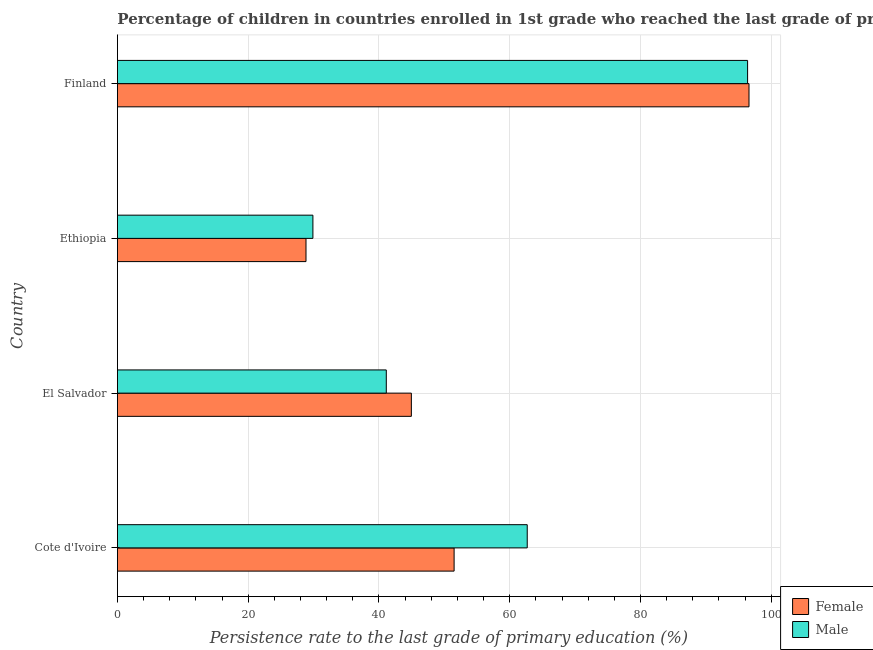How many different coloured bars are there?
Ensure brevity in your answer.  2. How many groups of bars are there?
Your answer should be very brief. 4. Are the number of bars per tick equal to the number of legend labels?
Ensure brevity in your answer.  Yes. How many bars are there on the 3rd tick from the top?
Your response must be concise. 2. How many bars are there on the 3rd tick from the bottom?
Your answer should be compact. 2. In how many cases, is the number of bars for a given country not equal to the number of legend labels?
Offer a very short reply. 0. What is the persistence rate of female students in Ethiopia?
Keep it short and to the point. 28.84. Across all countries, what is the maximum persistence rate of female students?
Offer a very short reply. 96.59. Across all countries, what is the minimum persistence rate of male students?
Provide a short and direct response. 29.9. In which country was the persistence rate of female students minimum?
Provide a succinct answer. Ethiopia. What is the total persistence rate of male students in the graph?
Offer a very short reply. 230.08. What is the difference between the persistence rate of male students in El Salvador and that in Ethiopia?
Provide a short and direct response. 11.22. What is the difference between the persistence rate of male students in Finland and the persistence rate of female students in El Salvador?
Your answer should be very brief. 51.42. What is the average persistence rate of male students per country?
Keep it short and to the point. 57.52. What is the difference between the persistence rate of male students and persistence rate of female students in Cote d'Ivoire?
Your answer should be very brief. 11.18. What is the ratio of the persistence rate of female students in Ethiopia to that in Finland?
Offer a terse response. 0.3. Is the persistence rate of female students in Cote d'Ivoire less than that in El Salvador?
Ensure brevity in your answer.  No. What is the difference between the highest and the second highest persistence rate of female students?
Provide a short and direct response. 45.1. What is the difference between the highest and the lowest persistence rate of female students?
Offer a terse response. 67.75. What does the 2nd bar from the top in Finland represents?
Your response must be concise. Female. What does the 1st bar from the bottom in El Salvador represents?
Give a very brief answer. Female. Are all the bars in the graph horizontal?
Your response must be concise. Yes. How many countries are there in the graph?
Your answer should be very brief. 4. What is the difference between two consecutive major ticks on the X-axis?
Make the answer very short. 20. Does the graph contain grids?
Your answer should be very brief. Yes. Where does the legend appear in the graph?
Keep it short and to the point. Bottom right. How many legend labels are there?
Provide a succinct answer. 2. How are the legend labels stacked?
Provide a succinct answer. Vertical. What is the title of the graph?
Provide a short and direct response. Percentage of children in countries enrolled in 1st grade who reached the last grade of primary education. What is the label or title of the X-axis?
Make the answer very short. Persistence rate to the last grade of primary education (%). What is the Persistence rate to the last grade of primary education (%) of Female in Cote d'Ivoire?
Make the answer very short. 51.49. What is the Persistence rate to the last grade of primary education (%) of Male in Cote d'Ivoire?
Your answer should be very brief. 62.68. What is the Persistence rate to the last grade of primary education (%) of Female in El Salvador?
Provide a succinct answer. 44.96. What is the Persistence rate to the last grade of primary education (%) in Male in El Salvador?
Provide a succinct answer. 41.12. What is the Persistence rate to the last grade of primary education (%) of Female in Ethiopia?
Offer a terse response. 28.84. What is the Persistence rate to the last grade of primary education (%) in Male in Ethiopia?
Your answer should be compact. 29.9. What is the Persistence rate to the last grade of primary education (%) in Female in Finland?
Make the answer very short. 96.59. What is the Persistence rate to the last grade of primary education (%) in Male in Finland?
Your answer should be compact. 96.38. Across all countries, what is the maximum Persistence rate to the last grade of primary education (%) in Female?
Ensure brevity in your answer.  96.59. Across all countries, what is the maximum Persistence rate to the last grade of primary education (%) in Male?
Offer a terse response. 96.38. Across all countries, what is the minimum Persistence rate to the last grade of primary education (%) of Female?
Give a very brief answer. 28.84. Across all countries, what is the minimum Persistence rate to the last grade of primary education (%) of Male?
Provide a succinct answer. 29.9. What is the total Persistence rate to the last grade of primary education (%) in Female in the graph?
Give a very brief answer. 221.88. What is the total Persistence rate to the last grade of primary education (%) of Male in the graph?
Offer a terse response. 230.08. What is the difference between the Persistence rate to the last grade of primary education (%) in Female in Cote d'Ivoire and that in El Salvador?
Provide a succinct answer. 6.54. What is the difference between the Persistence rate to the last grade of primary education (%) of Male in Cote d'Ivoire and that in El Salvador?
Provide a short and direct response. 21.55. What is the difference between the Persistence rate to the last grade of primary education (%) of Female in Cote d'Ivoire and that in Ethiopia?
Ensure brevity in your answer.  22.65. What is the difference between the Persistence rate to the last grade of primary education (%) of Male in Cote d'Ivoire and that in Ethiopia?
Your answer should be very brief. 32.78. What is the difference between the Persistence rate to the last grade of primary education (%) in Female in Cote d'Ivoire and that in Finland?
Your response must be concise. -45.1. What is the difference between the Persistence rate to the last grade of primary education (%) of Male in Cote d'Ivoire and that in Finland?
Your answer should be compact. -33.7. What is the difference between the Persistence rate to the last grade of primary education (%) in Female in El Salvador and that in Ethiopia?
Provide a short and direct response. 16.11. What is the difference between the Persistence rate to the last grade of primary education (%) in Male in El Salvador and that in Ethiopia?
Make the answer very short. 11.22. What is the difference between the Persistence rate to the last grade of primary education (%) of Female in El Salvador and that in Finland?
Keep it short and to the point. -51.64. What is the difference between the Persistence rate to the last grade of primary education (%) of Male in El Salvador and that in Finland?
Offer a terse response. -55.25. What is the difference between the Persistence rate to the last grade of primary education (%) in Female in Ethiopia and that in Finland?
Your answer should be compact. -67.75. What is the difference between the Persistence rate to the last grade of primary education (%) in Male in Ethiopia and that in Finland?
Provide a short and direct response. -66.48. What is the difference between the Persistence rate to the last grade of primary education (%) in Female in Cote d'Ivoire and the Persistence rate to the last grade of primary education (%) in Male in El Salvador?
Ensure brevity in your answer.  10.37. What is the difference between the Persistence rate to the last grade of primary education (%) of Female in Cote d'Ivoire and the Persistence rate to the last grade of primary education (%) of Male in Ethiopia?
Ensure brevity in your answer.  21.59. What is the difference between the Persistence rate to the last grade of primary education (%) of Female in Cote d'Ivoire and the Persistence rate to the last grade of primary education (%) of Male in Finland?
Provide a short and direct response. -44.88. What is the difference between the Persistence rate to the last grade of primary education (%) in Female in El Salvador and the Persistence rate to the last grade of primary education (%) in Male in Ethiopia?
Your response must be concise. 15.06. What is the difference between the Persistence rate to the last grade of primary education (%) in Female in El Salvador and the Persistence rate to the last grade of primary education (%) in Male in Finland?
Provide a succinct answer. -51.42. What is the difference between the Persistence rate to the last grade of primary education (%) of Female in Ethiopia and the Persistence rate to the last grade of primary education (%) of Male in Finland?
Provide a short and direct response. -67.53. What is the average Persistence rate to the last grade of primary education (%) in Female per country?
Ensure brevity in your answer.  55.47. What is the average Persistence rate to the last grade of primary education (%) in Male per country?
Give a very brief answer. 57.52. What is the difference between the Persistence rate to the last grade of primary education (%) of Female and Persistence rate to the last grade of primary education (%) of Male in Cote d'Ivoire?
Offer a very short reply. -11.18. What is the difference between the Persistence rate to the last grade of primary education (%) in Female and Persistence rate to the last grade of primary education (%) in Male in El Salvador?
Provide a succinct answer. 3.83. What is the difference between the Persistence rate to the last grade of primary education (%) of Female and Persistence rate to the last grade of primary education (%) of Male in Ethiopia?
Your answer should be very brief. -1.06. What is the difference between the Persistence rate to the last grade of primary education (%) in Female and Persistence rate to the last grade of primary education (%) in Male in Finland?
Provide a short and direct response. 0.22. What is the ratio of the Persistence rate to the last grade of primary education (%) in Female in Cote d'Ivoire to that in El Salvador?
Your response must be concise. 1.15. What is the ratio of the Persistence rate to the last grade of primary education (%) of Male in Cote d'Ivoire to that in El Salvador?
Provide a short and direct response. 1.52. What is the ratio of the Persistence rate to the last grade of primary education (%) of Female in Cote d'Ivoire to that in Ethiopia?
Your answer should be compact. 1.79. What is the ratio of the Persistence rate to the last grade of primary education (%) of Male in Cote d'Ivoire to that in Ethiopia?
Your answer should be compact. 2.1. What is the ratio of the Persistence rate to the last grade of primary education (%) of Female in Cote d'Ivoire to that in Finland?
Give a very brief answer. 0.53. What is the ratio of the Persistence rate to the last grade of primary education (%) of Male in Cote d'Ivoire to that in Finland?
Provide a short and direct response. 0.65. What is the ratio of the Persistence rate to the last grade of primary education (%) of Female in El Salvador to that in Ethiopia?
Provide a succinct answer. 1.56. What is the ratio of the Persistence rate to the last grade of primary education (%) of Male in El Salvador to that in Ethiopia?
Give a very brief answer. 1.38. What is the ratio of the Persistence rate to the last grade of primary education (%) in Female in El Salvador to that in Finland?
Offer a very short reply. 0.47. What is the ratio of the Persistence rate to the last grade of primary education (%) in Male in El Salvador to that in Finland?
Your response must be concise. 0.43. What is the ratio of the Persistence rate to the last grade of primary education (%) in Female in Ethiopia to that in Finland?
Keep it short and to the point. 0.3. What is the ratio of the Persistence rate to the last grade of primary education (%) in Male in Ethiopia to that in Finland?
Ensure brevity in your answer.  0.31. What is the difference between the highest and the second highest Persistence rate to the last grade of primary education (%) in Female?
Make the answer very short. 45.1. What is the difference between the highest and the second highest Persistence rate to the last grade of primary education (%) of Male?
Keep it short and to the point. 33.7. What is the difference between the highest and the lowest Persistence rate to the last grade of primary education (%) in Female?
Offer a very short reply. 67.75. What is the difference between the highest and the lowest Persistence rate to the last grade of primary education (%) in Male?
Your answer should be very brief. 66.48. 